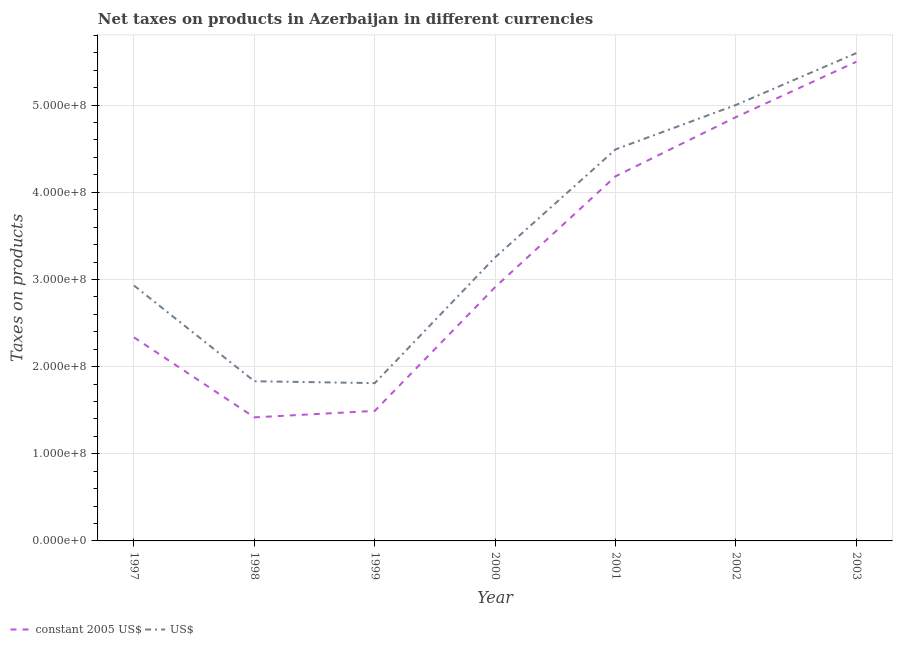What is the net taxes in constant 2005 us$ in 1999?
Your answer should be very brief. 1.49e+08. Across all years, what is the maximum net taxes in constant 2005 us$?
Offer a terse response. 5.50e+08. Across all years, what is the minimum net taxes in constant 2005 us$?
Your answer should be compact. 1.42e+08. In which year was the net taxes in constant 2005 us$ maximum?
Make the answer very short. 2003. What is the total net taxes in constant 2005 us$ in the graph?
Provide a short and direct response. 2.27e+09. What is the difference between the net taxes in us$ in 1997 and that in 2000?
Offer a very short reply. -3.24e+07. What is the difference between the net taxes in us$ in 2002 and the net taxes in constant 2005 us$ in 1999?
Your answer should be very brief. 3.51e+08. What is the average net taxes in us$ per year?
Give a very brief answer. 3.56e+08. In the year 1997, what is the difference between the net taxes in constant 2005 us$ and net taxes in us$?
Provide a succinct answer. -5.95e+07. What is the ratio of the net taxes in us$ in 1999 to that in 2000?
Give a very brief answer. 0.56. Is the net taxes in us$ in 1998 less than that in 2003?
Make the answer very short. Yes. What is the difference between the highest and the second highest net taxes in us$?
Your answer should be very brief. 5.95e+07. What is the difference between the highest and the lowest net taxes in us$?
Your answer should be very brief. 3.79e+08. Is the sum of the net taxes in constant 2005 us$ in 1999 and 2002 greater than the maximum net taxes in us$ across all years?
Your response must be concise. Yes. Does the net taxes in constant 2005 us$ monotonically increase over the years?
Make the answer very short. No. Is the net taxes in constant 2005 us$ strictly greater than the net taxes in us$ over the years?
Offer a very short reply. No. Is the net taxes in us$ strictly less than the net taxes in constant 2005 us$ over the years?
Provide a succinct answer. No. How many lines are there?
Keep it short and to the point. 2. What is the difference between two consecutive major ticks on the Y-axis?
Make the answer very short. 1.00e+08. Does the graph contain any zero values?
Make the answer very short. No. Does the graph contain grids?
Offer a terse response. Yes. How many legend labels are there?
Provide a short and direct response. 2. What is the title of the graph?
Your answer should be very brief. Net taxes on products in Azerbaijan in different currencies. Does "Resident workers" appear as one of the legend labels in the graph?
Your answer should be very brief. No. What is the label or title of the X-axis?
Offer a very short reply. Year. What is the label or title of the Y-axis?
Offer a very short reply. Taxes on products. What is the Taxes on products in constant 2005 US$ in 1997?
Give a very brief answer. 2.34e+08. What is the Taxes on products of US$ in 1997?
Your answer should be very brief. 2.93e+08. What is the Taxes on products in constant 2005 US$ in 1998?
Offer a terse response. 1.42e+08. What is the Taxes on products in US$ in 1998?
Keep it short and to the point. 1.83e+08. What is the Taxes on products of constant 2005 US$ in 1999?
Provide a short and direct response. 1.49e+08. What is the Taxes on products in US$ in 1999?
Your answer should be very brief. 1.81e+08. What is the Taxes on products in constant 2005 US$ in 2000?
Keep it short and to the point. 2.91e+08. What is the Taxes on products in US$ in 2000?
Provide a succinct answer. 3.25e+08. What is the Taxes on products of constant 2005 US$ in 2001?
Make the answer very short. 4.18e+08. What is the Taxes on products of US$ in 2001?
Your answer should be very brief. 4.49e+08. What is the Taxes on products in constant 2005 US$ in 2002?
Your response must be concise. 4.86e+08. What is the Taxes on products in US$ in 2002?
Ensure brevity in your answer.  5.00e+08. What is the Taxes on products of constant 2005 US$ in 2003?
Your response must be concise. 5.50e+08. What is the Taxes on products of US$ in 2003?
Make the answer very short. 5.60e+08. Across all years, what is the maximum Taxes on products in constant 2005 US$?
Your answer should be very brief. 5.50e+08. Across all years, what is the maximum Taxes on products in US$?
Your answer should be very brief. 5.60e+08. Across all years, what is the minimum Taxes on products of constant 2005 US$?
Your response must be concise. 1.42e+08. Across all years, what is the minimum Taxes on products in US$?
Offer a very short reply. 1.81e+08. What is the total Taxes on products of constant 2005 US$ in the graph?
Ensure brevity in your answer.  2.27e+09. What is the total Taxes on products of US$ in the graph?
Provide a short and direct response. 2.49e+09. What is the difference between the Taxes on products in constant 2005 US$ in 1997 and that in 1998?
Your answer should be compact. 9.18e+07. What is the difference between the Taxes on products in US$ in 1997 and that in 1998?
Offer a very short reply. 1.10e+08. What is the difference between the Taxes on products in constant 2005 US$ in 1997 and that in 1999?
Make the answer very short. 8.44e+07. What is the difference between the Taxes on products in US$ in 1997 and that in 1999?
Your answer should be very brief. 1.12e+08. What is the difference between the Taxes on products in constant 2005 US$ in 1997 and that in 2000?
Offer a terse response. -5.77e+07. What is the difference between the Taxes on products in US$ in 1997 and that in 2000?
Offer a terse response. -3.24e+07. What is the difference between the Taxes on products of constant 2005 US$ in 1997 and that in 2001?
Your answer should be compact. -1.85e+08. What is the difference between the Taxes on products in US$ in 1997 and that in 2001?
Offer a terse response. -1.56e+08. What is the difference between the Taxes on products in constant 2005 US$ in 1997 and that in 2002?
Offer a terse response. -2.53e+08. What is the difference between the Taxes on products in US$ in 1997 and that in 2002?
Your answer should be compact. -2.07e+08. What is the difference between the Taxes on products of constant 2005 US$ in 1997 and that in 2003?
Your answer should be compact. -3.16e+08. What is the difference between the Taxes on products of US$ in 1997 and that in 2003?
Your response must be concise. -2.67e+08. What is the difference between the Taxes on products of constant 2005 US$ in 1998 and that in 1999?
Your answer should be very brief. -7.42e+06. What is the difference between the Taxes on products of US$ in 1998 and that in 1999?
Your response must be concise. 2.16e+06. What is the difference between the Taxes on products of constant 2005 US$ in 1998 and that in 2000?
Offer a very short reply. -1.49e+08. What is the difference between the Taxes on products in US$ in 1998 and that in 2000?
Ensure brevity in your answer.  -1.42e+08. What is the difference between the Taxes on products in constant 2005 US$ in 1998 and that in 2001?
Offer a very short reply. -2.77e+08. What is the difference between the Taxes on products in US$ in 1998 and that in 2001?
Your answer should be very brief. -2.66e+08. What is the difference between the Taxes on products in constant 2005 US$ in 1998 and that in 2002?
Offer a very short reply. -3.44e+08. What is the difference between the Taxes on products in US$ in 1998 and that in 2002?
Provide a succinct answer. -3.17e+08. What is the difference between the Taxes on products of constant 2005 US$ in 1998 and that in 2003?
Your response must be concise. -4.08e+08. What is the difference between the Taxes on products of US$ in 1998 and that in 2003?
Keep it short and to the point. -3.76e+08. What is the difference between the Taxes on products in constant 2005 US$ in 1999 and that in 2000?
Provide a short and direct response. -1.42e+08. What is the difference between the Taxes on products in US$ in 1999 and that in 2000?
Ensure brevity in your answer.  -1.44e+08. What is the difference between the Taxes on products of constant 2005 US$ in 1999 and that in 2001?
Provide a succinct answer. -2.69e+08. What is the difference between the Taxes on products in US$ in 1999 and that in 2001?
Provide a succinct answer. -2.68e+08. What is the difference between the Taxes on products in constant 2005 US$ in 1999 and that in 2002?
Give a very brief answer. -3.37e+08. What is the difference between the Taxes on products in US$ in 1999 and that in 2002?
Your answer should be compact. -3.19e+08. What is the difference between the Taxes on products of constant 2005 US$ in 1999 and that in 2003?
Ensure brevity in your answer.  -4.01e+08. What is the difference between the Taxes on products of US$ in 1999 and that in 2003?
Give a very brief answer. -3.79e+08. What is the difference between the Taxes on products of constant 2005 US$ in 2000 and that in 2001?
Your response must be concise. -1.27e+08. What is the difference between the Taxes on products of US$ in 2000 and that in 2001?
Your response must be concise. -1.24e+08. What is the difference between the Taxes on products in constant 2005 US$ in 2000 and that in 2002?
Provide a short and direct response. -1.95e+08. What is the difference between the Taxes on products in US$ in 2000 and that in 2002?
Your answer should be compact. -1.75e+08. What is the difference between the Taxes on products of constant 2005 US$ in 2000 and that in 2003?
Your response must be concise. -2.59e+08. What is the difference between the Taxes on products in US$ in 2000 and that in 2003?
Offer a very short reply. -2.34e+08. What is the difference between the Taxes on products in constant 2005 US$ in 2001 and that in 2002?
Offer a terse response. -6.79e+07. What is the difference between the Taxes on products of US$ in 2001 and that in 2002?
Your answer should be very brief. -5.09e+07. What is the difference between the Taxes on products of constant 2005 US$ in 2001 and that in 2003?
Ensure brevity in your answer.  -1.31e+08. What is the difference between the Taxes on products in US$ in 2001 and that in 2003?
Offer a very short reply. -1.10e+08. What is the difference between the Taxes on products of constant 2005 US$ in 2002 and that in 2003?
Provide a succinct answer. -6.35e+07. What is the difference between the Taxes on products in US$ in 2002 and that in 2003?
Ensure brevity in your answer.  -5.95e+07. What is the difference between the Taxes on products of constant 2005 US$ in 1997 and the Taxes on products of US$ in 1998?
Ensure brevity in your answer.  5.03e+07. What is the difference between the Taxes on products of constant 2005 US$ in 1997 and the Taxes on products of US$ in 1999?
Keep it short and to the point. 5.25e+07. What is the difference between the Taxes on products in constant 2005 US$ in 1997 and the Taxes on products in US$ in 2000?
Your response must be concise. -9.19e+07. What is the difference between the Taxes on products in constant 2005 US$ in 1997 and the Taxes on products in US$ in 2001?
Provide a succinct answer. -2.16e+08. What is the difference between the Taxes on products of constant 2005 US$ in 1997 and the Taxes on products of US$ in 2002?
Your response must be concise. -2.67e+08. What is the difference between the Taxes on products in constant 2005 US$ in 1997 and the Taxes on products in US$ in 2003?
Offer a very short reply. -3.26e+08. What is the difference between the Taxes on products in constant 2005 US$ in 1998 and the Taxes on products in US$ in 1999?
Keep it short and to the point. -3.93e+07. What is the difference between the Taxes on products of constant 2005 US$ in 1998 and the Taxes on products of US$ in 2000?
Your answer should be compact. -1.84e+08. What is the difference between the Taxes on products in constant 2005 US$ in 1998 and the Taxes on products in US$ in 2001?
Provide a succinct answer. -3.07e+08. What is the difference between the Taxes on products of constant 2005 US$ in 1998 and the Taxes on products of US$ in 2002?
Provide a succinct answer. -3.58e+08. What is the difference between the Taxes on products in constant 2005 US$ in 1998 and the Taxes on products in US$ in 2003?
Your answer should be compact. -4.18e+08. What is the difference between the Taxes on products in constant 2005 US$ in 1999 and the Taxes on products in US$ in 2000?
Your answer should be very brief. -1.76e+08. What is the difference between the Taxes on products in constant 2005 US$ in 1999 and the Taxes on products in US$ in 2001?
Provide a short and direct response. -3.00e+08. What is the difference between the Taxes on products in constant 2005 US$ in 1999 and the Taxes on products in US$ in 2002?
Make the answer very short. -3.51e+08. What is the difference between the Taxes on products in constant 2005 US$ in 1999 and the Taxes on products in US$ in 2003?
Your response must be concise. -4.11e+08. What is the difference between the Taxes on products in constant 2005 US$ in 2000 and the Taxes on products in US$ in 2001?
Ensure brevity in your answer.  -1.58e+08. What is the difference between the Taxes on products in constant 2005 US$ in 2000 and the Taxes on products in US$ in 2002?
Provide a succinct answer. -2.09e+08. What is the difference between the Taxes on products of constant 2005 US$ in 2000 and the Taxes on products of US$ in 2003?
Your answer should be compact. -2.68e+08. What is the difference between the Taxes on products in constant 2005 US$ in 2001 and the Taxes on products in US$ in 2002?
Your answer should be compact. -8.18e+07. What is the difference between the Taxes on products of constant 2005 US$ in 2001 and the Taxes on products of US$ in 2003?
Offer a very short reply. -1.41e+08. What is the difference between the Taxes on products of constant 2005 US$ in 2002 and the Taxes on products of US$ in 2003?
Provide a short and direct response. -7.34e+07. What is the average Taxes on products in constant 2005 US$ per year?
Provide a succinct answer. 3.24e+08. What is the average Taxes on products of US$ per year?
Provide a short and direct response. 3.56e+08. In the year 1997, what is the difference between the Taxes on products of constant 2005 US$ and Taxes on products of US$?
Keep it short and to the point. -5.95e+07. In the year 1998, what is the difference between the Taxes on products of constant 2005 US$ and Taxes on products of US$?
Give a very brief answer. -4.14e+07. In the year 1999, what is the difference between the Taxes on products of constant 2005 US$ and Taxes on products of US$?
Your response must be concise. -3.19e+07. In the year 2000, what is the difference between the Taxes on products of constant 2005 US$ and Taxes on products of US$?
Provide a succinct answer. -3.42e+07. In the year 2001, what is the difference between the Taxes on products in constant 2005 US$ and Taxes on products in US$?
Provide a short and direct response. -3.09e+07. In the year 2002, what is the difference between the Taxes on products in constant 2005 US$ and Taxes on products in US$?
Your answer should be compact. -1.39e+07. In the year 2003, what is the difference between the Taxes on products in constant 2005 US$ and Taxes on products in US$?
Give a very brief answer. -9.94e+06. What is the ratio of the Taxes on products in constant 2005 US$ in 1997 to that in 1998?
Keep it short and to the point. 1.65. What is the ratio of the Taxes on products of US$ in 1997 to that in 1998?
Your answer should be compact. 1.6. What is the ratio of the Taxes on products of constant 2005 US$ in 1997 to that in 1999?
Your answer should be compact. 1.57. What is the ratio of the Taxes on products of US$ in 1997 to that in 1999?
Keep it short and to the point. 1.62. What is the ratio of the Taxes on products of constant 2005 US$ in 1997 to that in 2000?
Your answer should be compact. 0.8. What is the ratio of the Taxes on products of US$ in 1997 to that in 2000?
Your answer should be compact. 0.9. What is the ratio of the Taxes on products in constant 2005 US$ in 1997 to that in 2001?
Your response must be concise. 0.56. What is the ratio of the Taxes on products in US$ in 1997 to that in 2001?
Give a very brief answer. 0.65. What is the ratio of the Taxes on products in constant 2005 US$ in 1997 to that in 2002?
Provide a short and direct response. 0.48. What is the ratio of the Taxes on products in US$ in 1997 to that in 2002?
Your response must be concise. 0.59. What is the ratio of the Taxes on products of constant 2005 US$ in 1997 to that in 2003?
Provide a short and direct response. 0.42. What is the ratio of the Taxes on products of US$ in 1997 to that in 2003?
Your answer should be compact. 0.52. What is the ratio of the Taxes on products in constant 2005 US$ in 1998 to that in 1999?
Offer a terse response. 0.95. What is the ratio of the Taxes on products in constant 2005 US$ in 1998 to that in 2000?
Offer a very short reply. 0.49. What is the ratio of the Taxes on products in US$ in 1998 to that in 2000?
Your answer should be very brief. 0.56. What is the ratio of the Taxes on products of constant 2005 US$ in 1998 to that in 2001?
Provide a short and direct response. 0.34. What is the ratio of the Taxes on products of US$ in 1998 to that in 2001?
Offer a very short reply. 0.41. What is the ratio of the Taxes on products of constant 2005 US$ in 1998 to that in 2002?
Make the answer very short. 0.29. What is the ratio of the Taxes on products of US$ in 1998 to that in 2002?
Offer a very short reply. 0.37. What is the ratio of the Taxes on products of constant 2005 US$ in 1998 to that in 2003?
Make the answer very short. 0.26. What is the ratio of the Taxes on products in US$ in 1998 to that in 2003?
Offer a very short reply. 0.33. What is the ratio of the Taxes on products in constant 2005 US$ in 1999 to that in 2000?
Your response must be concise. 0.51. What is the ratio of the Taxes on products of US$ in 1999 to that in 2000?
Provide a succinct answer. 0.56. What is the ratio of the Taxes on products in constant 2005 US$ in 1999 to that in 2001?
Keep it short and to the point. 0.36. What is the ratio of the Taxes on products of US$ in 1999 to that in 2001?
Keep it short and to the point. 0.4. What is the ratio of the Taxes on products of constant 2005 US$ in 1999 to that in 2002?
Offer a terse response. 0.31. What is the ratio of the Taxes on products of US$ in 1999 to that in 2002?
Give a very brief answer. 0.36. What is the ratio of the Taxes on products in constant 2005 US$ in 1999 to that in 2003?
Offer a very short reply. 0.27. What is the ratio of the Taxes on products in US$ in 1999 to that in 2003?
Ensure brevity in your answer.  0.32. What is the ratio of the Taxes on products of constant 2005 US$ in 2000 to that in 2001?
Your answer should be compact. 0.7. What is the ratio of the Taxes on products of US$ in 2000 to that in 2001?
Keep it short and to the point. 0.72. What is the ratio of the Taxes on products in constant 2005 US$ in 2000 to that in 2002?
Provide a succinct answer. 0.6. What is the ratio of the Taxes on products in US$ in 2000 to that in 2002?
Your answer should be very brief. 0.65. What is the ratio of the Taxes on products of constant 2005 US$ in 2000 to that in 2003?
Provide a succinct answer. 0.53. What is the ratio of the Taxes on products of US$ in 2000 to that in 2003?
Make the answer very short. 0.58. What is the ratio of the Taxes on products in constant 2005 US$ in 2001 to that in 2002?
Your answer should be compact. 0.86. What is the ratio of the Taxes on products of US$ in 2001 to that in 2002?
Offer a terse response. 0.9. What is the ratio of the Taxes on products in constant 2005 US$ in 2001 to that in 2003?
Provide a succinct answer. 0.76. What is the ratio of the Taxes on products of US$ in 2001 to that in 2003?
Your response must be concise. 0.8. What is the ratio of the Taxes on products in constant 2005 US$ in 2002 to that in 2003?
Offer a very short reply. 0.88. What is the ratio of the Taxes on products of US$ in 2002 to that in 2003?
Ensure brevity in your answer.  0.89. What is the difference between the highest and the second highest Taxes on products of constant 2005 US$?
Offer a terse response. 6.35e+07. What is the difference between the highest and the second highest Taxes on products in US$?
Offer a terse response. 5.95e+07. What is the difference between the highest and the lowest Taxes on products of constant 2005 US$?
Offer a terse response. 4.08e+08. What is the difference between the highest and the lowest Taxes on products in US$?
Your answer should be very brief. 3.79e+08. 